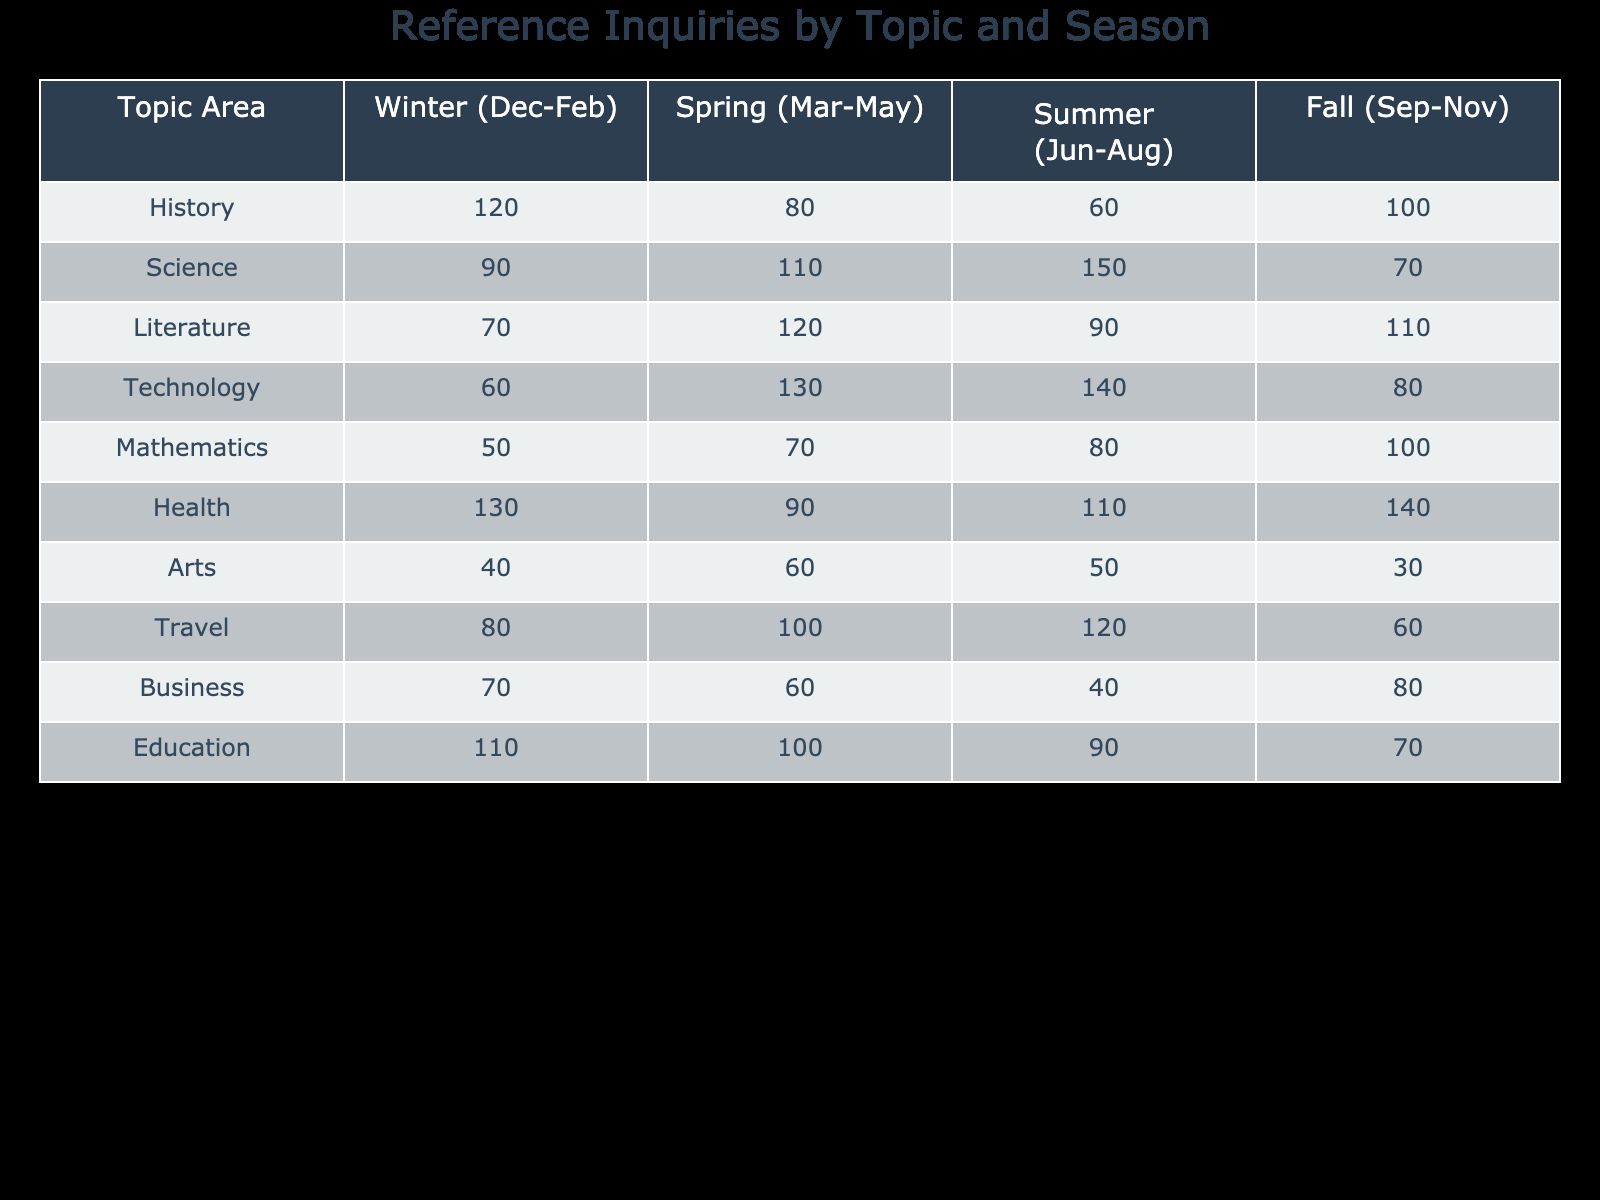What topic area received the most reference inquiries in the Spring season? In the Spring season, we look at the values for each topic area. The numbers are: History (80), Science (110), Literature (120), Technology (130), Mathematics (70), Health (90), Arts (60), Travel (100), Business (60), Education (100). The highest value is for Technology with 130 inquiries.
Answer: Technology Which topic area had the least number of reference inquiries in the Winter season? In the Winter season, we compare the values: History (120), Science (90), Literature (70), Technology (60), Mathematics (50), Health (130), Arts (40), Travel (80), Business (70), and Education (110). The least number of inquiries is found in Arts with 40 inquiries.
Answer: Arts What is the total number of reference inquiries categorized under Health for the entire year? To find the total for Health, we sum the inquiries from all seasons: Winter (130) + Spring (90) + Summer (110) + Fall (140) = 470. Thus, the total inquiries for Health is 470.
Answer: 470 Does Literature receive more inquiries in Spring than in Winter? In Spring, Literature has 120 inquiries and in Winter it has 70 inquiries. Since 120 (Spring) is greater than 70 (Winter), the statement is true.
Answer: Yes Which season has the highest total inquiries across all topic areas, and what is that total? We calculate the total for inquiries in each season: Winter = 120 + 90 + 70 + 60 + 50 + 130 + 40 + 80 + 70 + 110 = 800; Spring = 80 + 110 + 120 + 130 + 70 + 90 + 60 + 100 + 60 + 100 = 1020; Summer = 60 + 150 + 90 + 140 + 80 + 110 + 50 + 120 + 40 + 90 = 1030; Fall = 100 + 70 + 110 + 80 + 100 + 140 + 30 + 60 + 80 + 70 = 1030. Both Summer and Fall have the highest total, which is 1030.
Answer: Summer and Fall, 1030 How many more inquiries does Science receive in Summer compared to Autumn? For Science inquiries, in Summer there are 150, and in Autumn there are 70. To find the difference, we subtract: 150 (Summer) - 70 (Fall) = 80. Thus, Science receives 80 more inquiries in Summer than in Fall.
Answer: 80 